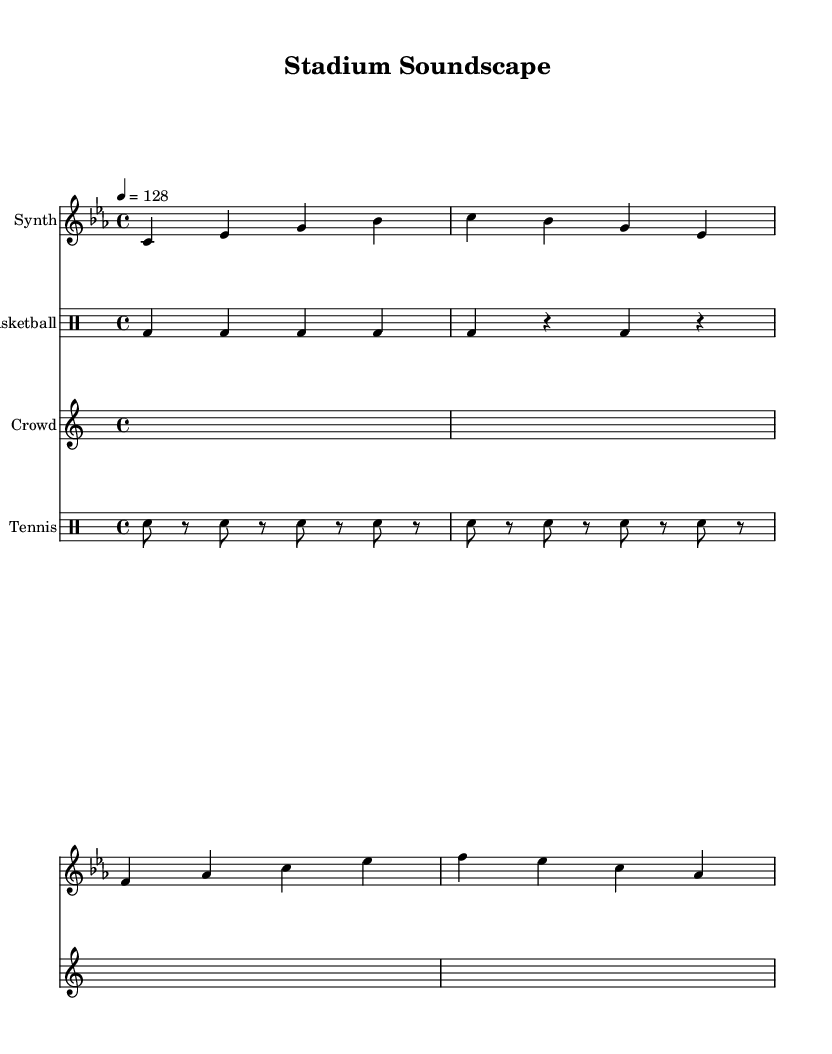What is the key signature of this music? The key signature is C minor, which has three flats (B♭, E♭, A♭). This is indicated at the beginning of the staff where the key signature is placed.
Answer: C minor What is the time signature of the piece? The time signature is 4/4, which means there are four beats in each measure and the quarter note receives one beat. This is directly indicated in the music notation.
Answer: 4/4 What is the tempo marking of the composition? The tempo marking is 128 beats per minute, as indicated by "4 = 128" at the beginning of the score. This means the quarter note is played at a speed of 128 beats in one minute.
Answer: 128 How many measures are in the synth part? The synth part consists of 4 measures, as indicated by the grouping of notes where each line represents one measure, and there are four distinct sections visible.
Answer: 4 What type of electronic components are used in this composition? The composition features synth sounds, basketball sound effects, crowd noise, and tennis racket sounds, indicating a mix of musical and environmental elements. This can be discerned from the instrument names and the types of notations used for each section.
Answer: Synth, basketball, crowd, tennis How does the basketball bounce rhythm relate to the overall tempo? The basketball bounce rhythm consists of quarter notes played consistently at a speed proportional to the beat of the piece, supporting the tempo of 128 BPM. Each 'bd' represents a beat aligning with the 4/4 time signature.
Answer: It follows the tempo What is the significance of the crowd cheer notation? The crowd cheer section consists of sustained silence (represented as "s1") repeating multiple times, creating a dynamic contrast and emphasizing the crowd's presence, which is a common feature in experimental electronic compositions to represent atmosphere.
Answer: Dynamic contrast 